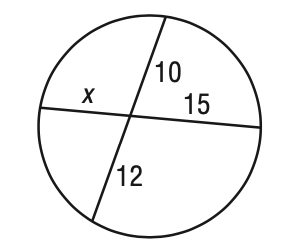Answer the mathemtical geometry problem and directly provide the correct option letter.
Question: Solve for x in the figure.
Choices: A: 8 B: 9 C: 10 D: 12 A 